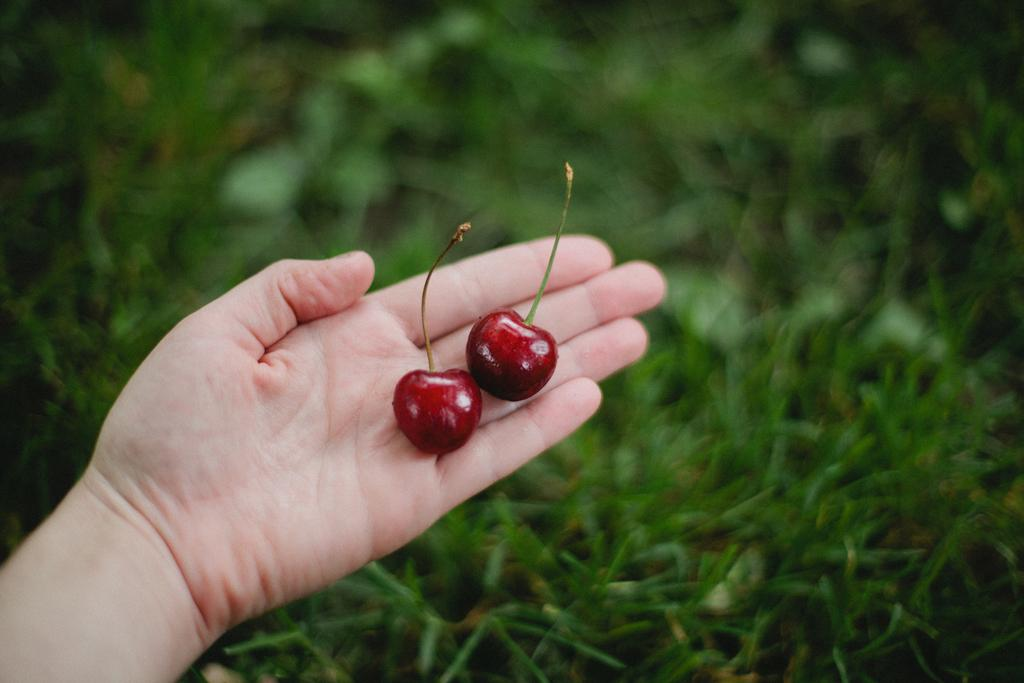What is the main subject of the picture? There is a person in the picture. What is the person holding in the image? The person is holding two berries. What can be seen in the background of the image? There is grass in the background of the image. How would you describe the background of the image? The background of the image is blurred. How many buttons can be seen on the person's shirt in the image? There is no information about the person's shirt or buttons in the image, so we cannot determine the number of buttons. What type of cakes are being served in the image? There are no cakes present in the image; it only features a person holding two berries. 